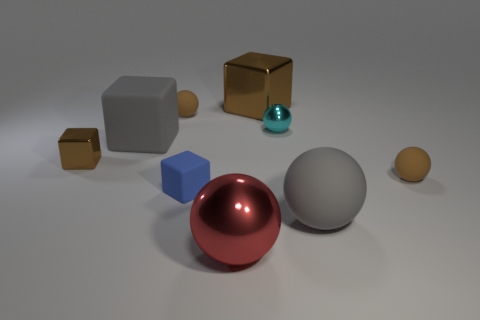Subtract 1 balls. How many balls are left? 4 Subtract all gray spheres. How many spheres are left? 4 Subtract all cyan balls. How many balls are left? 4 Subtract all blue balls. Subtract all cyan cylinders. How many balls are left? 5 Add 1 tiny metal blocks. How many objects exist? 10 Subtract all balls. How many objects are left? 4 Add 5 small brown matte things. How many small brown matte things are left? 7 Add 1 big blue matte objects. How many big blue matte objects exist? 1 Subtract 2 brown balls. How many objects are left? 7 Subtract all tiny brown rubber spheres. Subtract all metallic cubes. How many objects are left? 5 